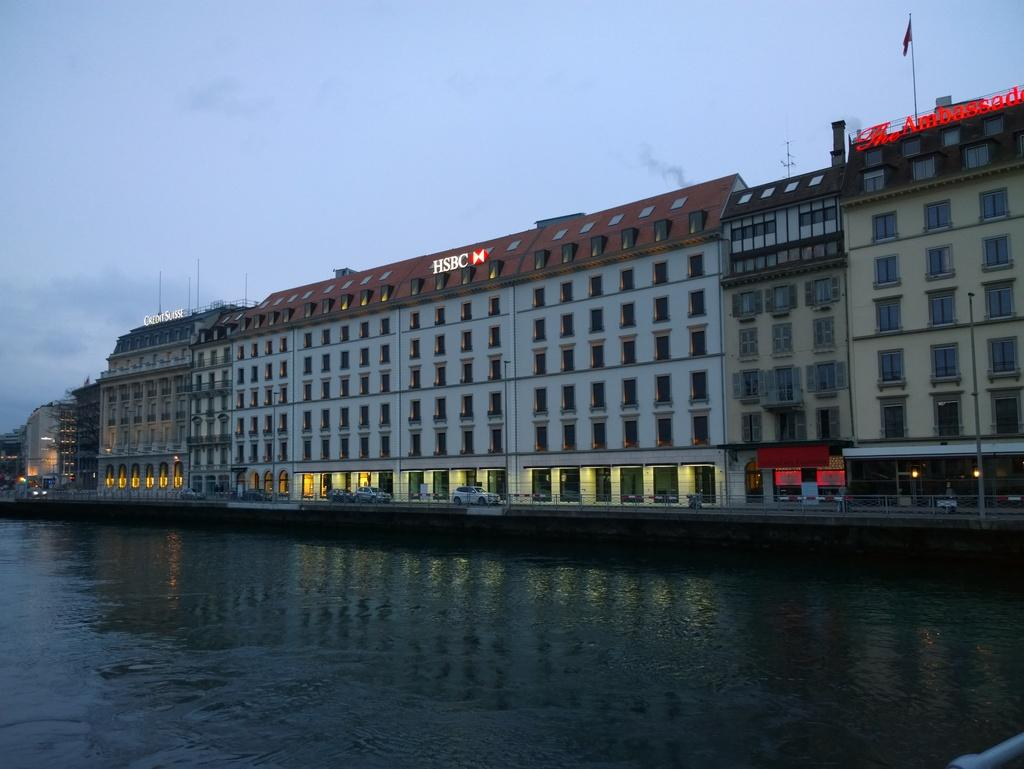What type of structure is present in the image? There is a building in the image. What can be seen on the building? There are name boards in the image. What is attached to the flag post? There is a flag in the image. Where is the flag post located? The flag post is in the image. What is visible in the sky? The sky is visible in the image, and there are clouds in the sky. What else can be seen in the image besides the building and sky? There is water visible in the image. What type of iron is used to make the stocking in the image? There is no iron or stocking present in the image. What is the tendency of the clouds in the image? The image does not indicate any specific tendency of the clouds; they are simply visible in the sky. 